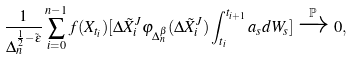Convert formula to latex. <formula><loc_0><loc_0><loc_500><loc_500>\frac { 1 } { \Delta _ { n } ^ { \frac { 1 } { 2 } - \tilde { \epsilon } } } \sum _ { i = 0 } ^ { n - 1 } f ( X _ { t _ { i } } ) [ \Delta \tilde { X } _ { i } ^ { J } \varphi _ { \Delta _ { n } ^ { \beta } } ( \Delta \tilde { X } _ { i } ^ { J } ) \int _ { t _ { i } } ^ { t _ { i + 1 } } a _ { s } d W _ { s } ] \xrightarrow { \mathbb { P } } 0 ,</formula> 